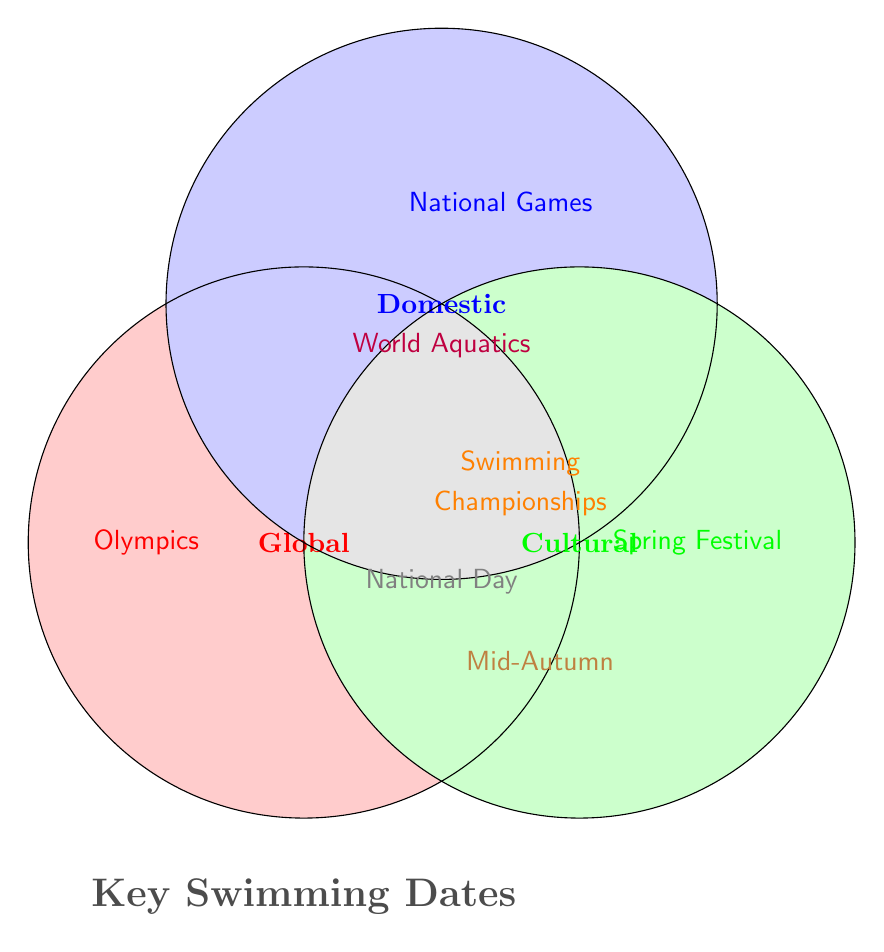Which event is categorized under 'Global' yet segmented away from other importance categories as per the Venn Diagram? The Venn Diagram specifically colors and places each event in distinct categories. 'Olympics' is uniquely placed solely in the 'Global' category without any overlap with other categories.
Answer: Olympics How many events fall exclusively into the 'Cultural' category? Based on the visual representation of the Venn Diagram, the 'Cultural' category includes 'Spring Festival' and is segmented away from any overlaps. This indicates it as the sole, separate event in that category.
Answer: 1 Which events have overlapping importance between 'Global' and 'Cultural'? By examining the overlapping sections, it can be observed that the Venn Diagram does not show any events falling under both the 'Global' and 'Cultural' categories simultaneously.
Answer: None What is the significance of 'National Day', and does it overlap with any other categories? According to the Venn Diagram, 'National Day' appears in the section that overlaps all three categories (Global, Domestic, Cultural). This indicates its importance spans across all mentioned categories.
Answer: All (Global, Domestic, Cultural) How many events are categorized exclusively as 'Domestic'? The Venn Diagram distinctly shows ‘National Games’ within the 'Domestic' category, with no intersection with others, pointing to it being the exclusive 'Domestic' event.
Answer: 1 Which event does the 'World Aquatics' fall under, and does it overlap with any categories? Upon examining the Venn Diagram, 'World Aquatics' is placed at the intersection of 'Global' and 'Domestic', indicating it belongs to both categories but not 'Cultural'.
Answer: Global and Domestic Among 'Global' and 'National' categories, which one contains 'Regional Qualifiers'? By scrutinizing the diagram, 'Regional Qualifiers' is notably missing, hence it is neither under 'Global' nor 'National'. Only the 'Local' category covers 'Regional Qualifiers'.
Answer: None (Only Local) Which event is positioned uniquely without overlapping with Cultural importance? The Venn Diagram places 'Olympics', 'World Aquatics', 'National Games', and 'Swimming Championships' outside of the 'Cultural' category, but the 'Olympics' notably stands without overlap with other categories.
Answer: Olympics 